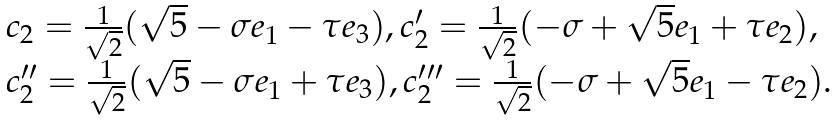Convert formula to latex. <formula><loc_0><loc_0><loc_500><loc_500>\begin{array} { l } c _ { 2 } = \frac { 1 } { \sqrt { 2 } } ( \sqrt { 5 } - \sigma e _ { 1 } - \tau e _ { 3 } ) , c ^ { \prime } _ { 2 } = \frac { 1 } { \sqrt { 2 } } ( - \sigma + \sqrt { 5 } e _ { 1 } + \tau e _ { 2 } ) , \\ c ^ { \prime \prime } _ { 2 } = \frac { 1 } { \sqrt { 2 } } ( \sqrt { 5 } - \sigma e _ { 1 } + \tau e _ { 3 } ) , c ^ { \prime \prime \prime } _ { 2 } = \frac { 1 } { \sqrt { 2 } } ( - \sigma + \sqrt { 5 } e _ { 1 } - \tau e _ { 2 } ) . \end{array}</formula> 